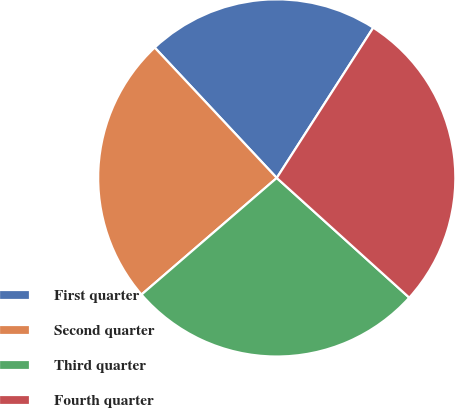<chart> <loc_0><loc_0><loc_500><loc_500><pie_chart><fcel>First quarter<fcel>Second quarter<fcel>Third quarter<fcel>Fourth quarter<nl><fcel>21.06%<fcel>24.35%<fcel>26.98%<fcel>27.61%<nl></chart> 